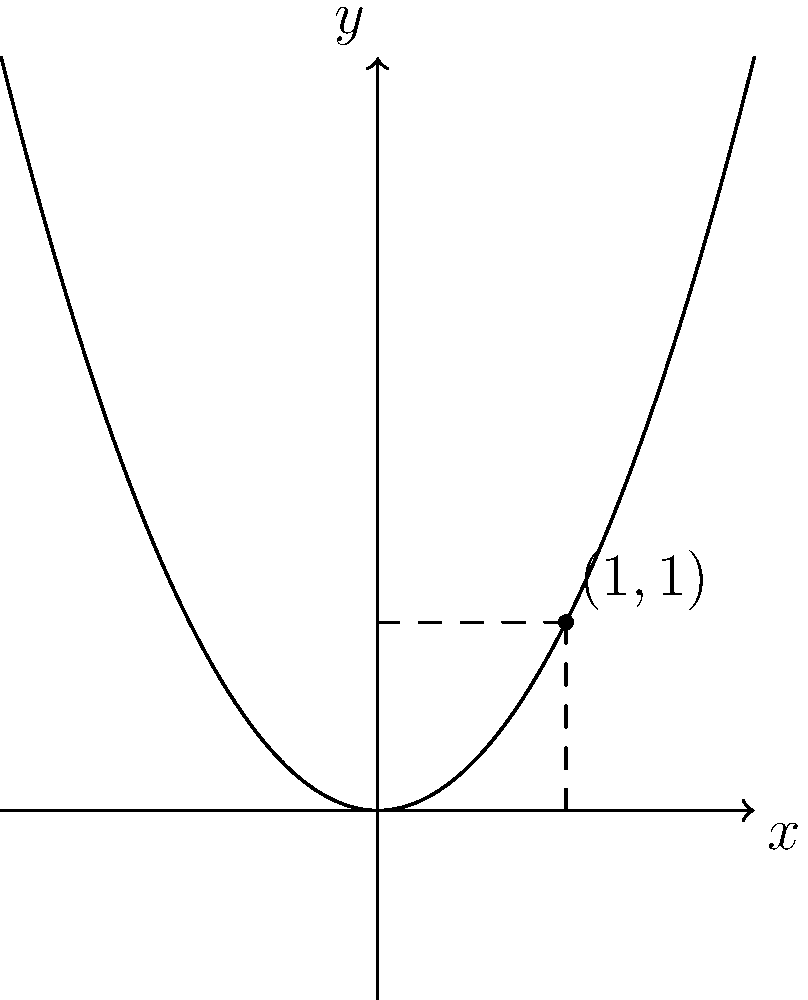A particle is moving along the parabolic path defined by $y = x^2$. At the point $(1, 1)$, calculate the instantaneous rate of change of the particle's vertical position with respect to its horizontal position. To find the instantaneous rate of change of the particle's vertical position with respect to its horizontal position, we need to calculate the derivative of the function $y = x^2$ at the point $(1, 1)$. Here's how we do it:

1) The function describing the particle's path is $y = x^2$.

2) To find the rate of change, we need to find $\frac{dy}{dx}$.

3) The derivative of $x^2$ is $2x$. So, $\frac{dy}{dx} = 2x$.

4) At the point $(1, 1)$, $x = 1$.

5) Substituting $x = 1$ into our derivative:
   $\frac{dy}{dx}|_{x=1} = 2(1) = 2$

Therefore, at the point $(1, 1)$, the instantaneous rate of change of the particle's vertical position with respect to its horizontal position is 2.
Answer: 2 